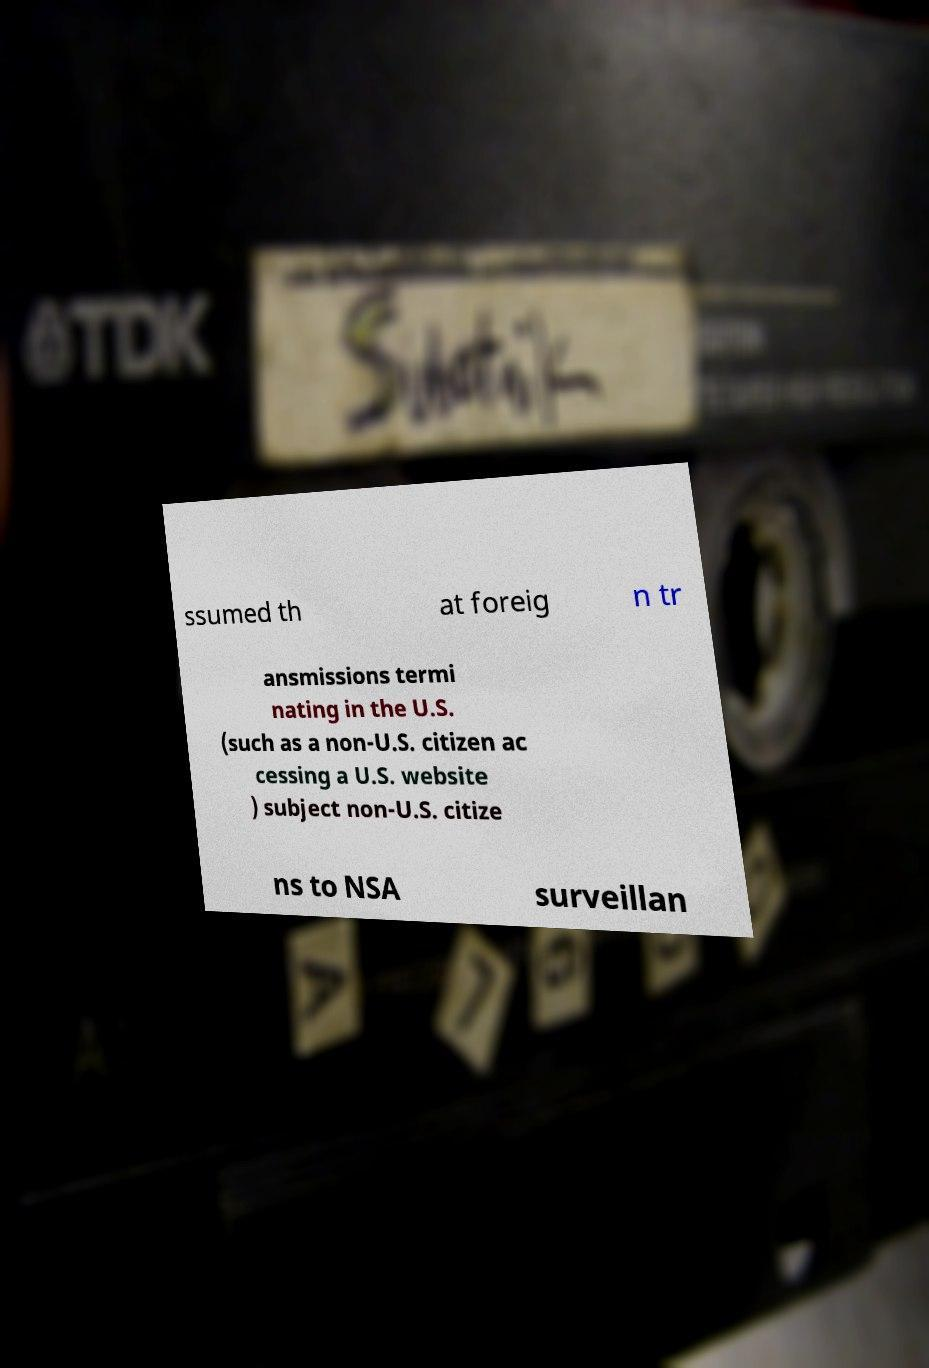Please read and relay the text visible in this image. What does it say? ssumed th at foreig n tr ansmissions termi nating in the U.S. (such as a non-U.S. citizen ac cessing a U.S. website ) subject non-U.S. citize ns to NSA surveillan 